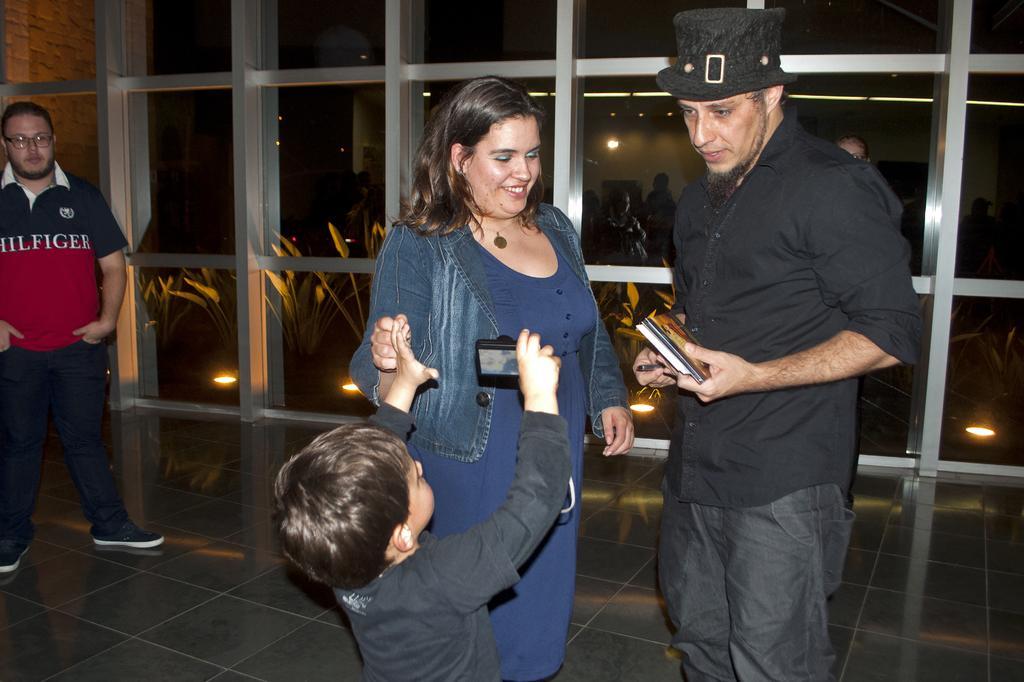Describe this image in one or two sentences. In this image there is a man who is standing on the floor by holding the books and pens. He is on the right side. Beside him there is a woman. In front of them there is a kid who is holding the camera. On the right side there is a man who is standing on the floor. In the background there are iron rods and glass in between them. At the bottom there are lights and plants. 